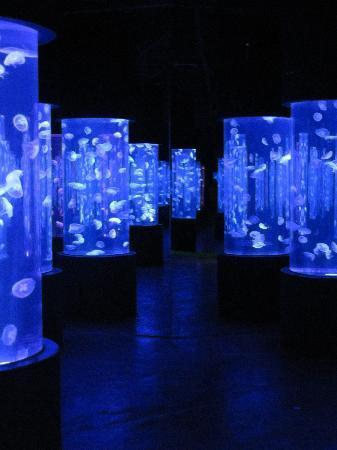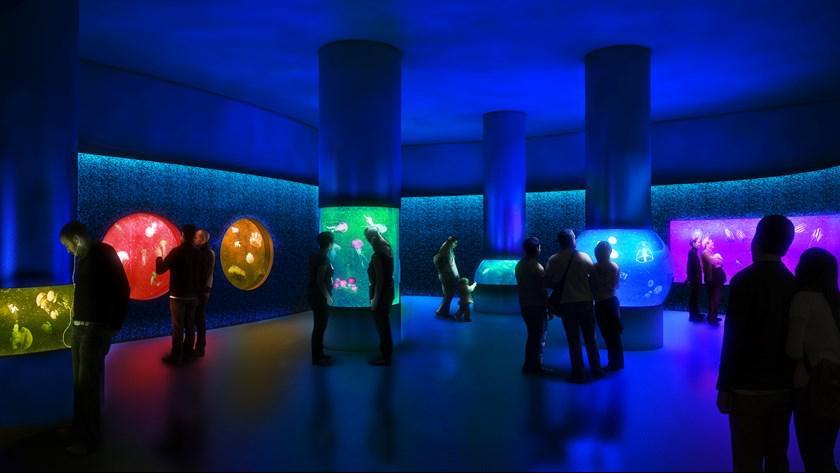The first image is the image on the left, the second image is the image on the right. Given the left and right images, does the statement "An aquarium consists of multiple well lit geometrical shaped enclosures that have many types of sea creatures inside." hold true? Answer yes or no. Yes. The first image is the image on the left, the second image is the image on the right. For the images displayed, is the sentence "multiple columned aquariums are holding jellyfish" factually correct? Answer yes or no. Yes. 